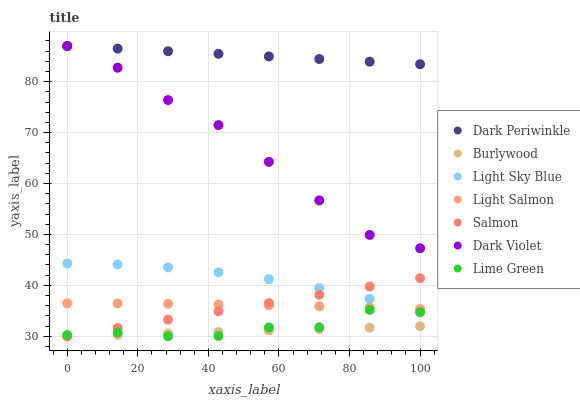Does Burlywood have the minimum area under the curve?
Answer yes or no. Yes. Does Dark Periwinkle have the maximum area under the curve?
Answer yes or no. Yes. Does Salmon have the minimum area under the curve?
Answer yes or no. No. Does Salmon have the maximum area under the curve?
Answer yes or no. No. Is Burlywood the smoothest?
Answer yes or no. Yes. Is Lime Green the roughest?
Answer yes or no. Yes. Is Salmon the smoothest?
Answer yes or no. No. Is Salmon the roughest?
Answer yes or no. No. Does Burlywood have the lowest value?
Answer yes or no. Yes. Does Dark Violet have the lowest value?
Answer yes or no. No. Does Dark Periwinkle have the highest value?
Answer yes or no. Yes. Does Salmon have the highest value?
Answer yes or no. No. Is Light Sky Blue less than Dark Violet?
Answer yes or no. Yes. Is Light Sky Blue greater than Lime Green?
Answer yes or no. Yes. Does Salmon intersect Lime Green?
Answer yes or no. Yes. Is Salmon less than Lime Green?
Answer yes or no. No. Is Salmon greater than Lime Green?
Answer yes or no. No. Does Light Sky Blue intersect Dark Violet?
Answer yes or no. No. 